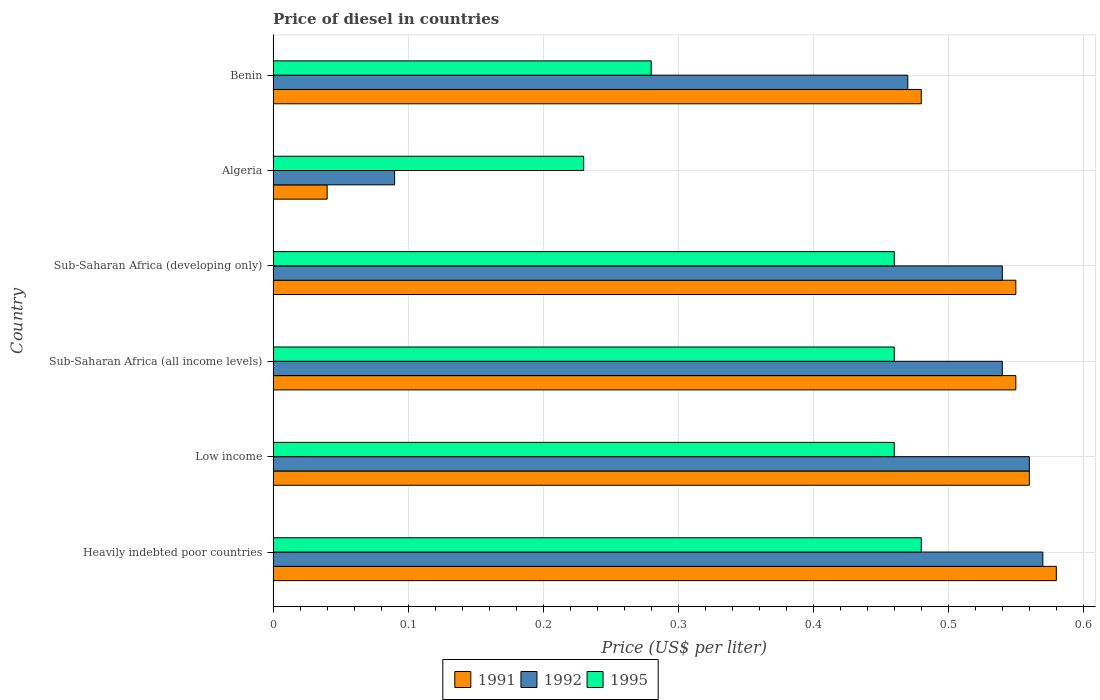How many different coloured bars are there?
Offer a very short reply. 3. How many groups of bars are there?
Ensure brevity in your answer.  6. How many bars are there on the 4th tick from the bottom?
Your response must be concise. 3. What is the label of the 3rd group of bars from the top?
Your answer should be very brief. Sub-Saharan Africa (developing only). What is the price of diesel in 1992 in Sub-Saharan Africa (developing only)?
Give a very brief answer. 0.54. Across all countries, what is the maximum price of diesel in 1991?
Keep it short and to the point. 0.58. Across all countries, what is the minimum price of diesel in 1992?
Your answer should be very brief. 0.09. In which country was the price of diesel in 1995 maximum?
Offer a terse response. Heavily indebted poor countries. In which country was the price of diesel in 1995 minimum?
Provide a succinct answer. Algeria. What is the total price of diesel in 1992 in the graph?
Offer a terse response. 2.77. What is the difference between the price of diesel in 1995 in Heavily indebted poor countries and that in Sub-Saharan Africa (developing only)?
Offer a very short reply. 0.02. What is the difference between the price of diesel in 1995 in Benin and the price of diesel in 1991 in Low income?
Your answer should be very brief. -0.28. What is the average price of diesel in 1992 per country?
Offer a very short reply. 0.46. What is the difference between the price of diesel in 1991 and price of diesel in 1992 in Sub-Saharan Africa (developing only)?
Your response must be concise. 0.01. What is the ratio of the price of diesel in 1991 in Sub-Saharan Africa (all income levels) to that in Sub-Saharan Africa (developing only)?
Your response must be concise. 1. Is the price of diesel in 1995 in Benin less than that in Sub-Saharan Africa (all income levels)?
Ensure brevity in your answer.  Yes. What is the difference between the highest and the second highest price of diesel in 1995?
Your response must be concise. 0.02. What is the difference between the highest and the lowest price of diesel in 1992?
Give a very brief answer. 0.48. In how many countries, is the price of diesel in 1992 greater than the average price of diesel in 1992 taken over all countries?
Offer a very short reply. 5. What does the 2nd bar from the top in Sub-Saharan Africa (developing only) represents?
Your answer should be very brief. 1992. Is it the case that in every country, the sum of the price of diesel in 1992 and price of diesel in 1995 is greater than the price of diesel in 1991?
Your answer should be compact. Yes. How many bars are there?
Provide a succinct answer. 18. Does the graph contain any zero values?
Offer a terse response. No. Does the graph contain grids?
Give a very brief answer. Yes. Where does the legend appear in the graph?
Offer a terse response. Bottom center. How many legend labels are there?
Give a very brief answer. 3. How are the legend labels stacked?
Your answer should be compact. Horizontal. What is the title of the graph?
Provide a succinct answer. Price of diesel in countries. Does "1969" appear as one of the legend labels in the graph?
Offer a very short reply. No. What is the label or title of the X-axis?
Ensure brevity in your answer.  Price (US$ per liter). What is the Price (US$ per liter) in 1991 in Heavily indebted poor countries?
Give a very brief answer. 0.58. What is the Price (US$ per liter) of 1992 in Heavily indebted poor countries?
Your answer should be very brief. 0.57. What is the Price (US$ per liter) in 1995 in Heavily indebted poor countries?
Keep it short and to the point. 0.48. What is the Price (US$ per liter) of 1991 in Low income?
Provide a succinct answer. 0.56. What is the Price (US$ per liter) in 1992 in Low income?
Give a very brief answer. 0.56. What is the Price (US$ per liter) in 1995 in Low income?
Your answer should be compact. 0.46. What is the Price (US$ per liter) in 1991 in Sub-Saharan Africa (all income levels)?
Offer a terse response. 0.55. What is the Price (US$ per liter) of 1992 in Sub-Saharan Africa (all income levels)?
Your answer should be compact. 0.54. What is the Price (US$ per liter) of 1995 in Sub-Saharan Africa (all income levels)?
Give a very brief answer. 0.46. What is the Price (US$ per liter) of 1991 in Sub-Saharan Africa (developing only)?
Provide a short and direct response. 0.55. What is the Price (US$ per liter) in 1992 in Sub-Saharan Africa (developing only)?
Your answer should be very brief. 0.54. What is the Price (US$ per liter) in 1995 in Sub-Saharan Africa (developing only)?
Your answer should be very brief. 0.46. What is the Price (US$ per liter) of 1992 in Algeria?
Give a very brief answer. 0.09. What is the Price (US$ per liter) in 1995 in Algeria?
Ensure brevity in your answer.  0.23. What is the Price (US$ per liter) in 1991 in Benin?
Your answer should be compact. 0.48. What is the Price (US$ per liter) in 1992 in Benin?
Your answer should be very brief. 0.47. What is the Price (US$ per liter) of 1995 in Benin?
Offer a terse response. 0.28. Across all countries, what is the maximum Price (US$ per liter) in 1991?
Give a very brief answer. 0.58. Across all countries, what is the maximum Price (US$ per liter) of 1992?
Offer a terse response. 0.57. Across all countries, what is the maximum Price (US$ per liter) in 1995?
Make the answer very short. 0.48. Across all countries, what is the minimum Price (US$ per liter) in 1992?
Keep it short and to the point. 0.09. Across all countries, what is the minimum Price (US$ per liter) in 1995?
Your answer should be very brief. 0.23. What is the total Price (US$ per liter) of 1991 in the graph?
Offer a very short reply. 2.76. What is the total Price (US$ per liter) in 1992 in the graph?
Provide a succinct answer. 2.77. What is the total Price (US$ per liter) of 1995 in the graph?
Ensure brevity in your answer.  2.37. What is the difference between the Price (US$ per liter) of 1995 in Heavily indebted poor countries and that in Sub-Saharan Africa (all income levels)?
Make the answer very short. 0.02. What is the difference between the Price (US$ per liter) in 1992 in Heavily indebted poor countries and that in Sub-Saharan Africa (developing only)?
Your response must be concise. 0.03. What is the difference between the Price (US$ per liter) of 1995 in Heavily indebted poor countries and that in Sub-Saharan Africa (developing only)?
Make the answer very short. 0.02. What is the difference between the Price (US$ per liter) in 1991 in Heavily indebted poor countries and that in Algeria?
Provide a short and direct response. 0.54. What is the difference between the Price (US$ per liter) in 1992 in Heavily indebted poor countries and that in Algeria?
Offer a terse response. 0.48. What is the difference between the Price (US$ per liter) in 1991 in Heavily indebted poor countries and that in Benin?
Give a very brief answer. 0.1. What is the difference between the Price (US$ per liter) of 1991 in Low income and that in Sub-Saharan Africa (all income levels)?
Keep it short and to the point. 0.01. What is the difference between the Price (US$ per liter) in 1995 in Low income and that in Sub-Saharan Africa (all income levels)?
Offer a very short reply. 0. What is the difference between the Price (US$ per liter) in 1992 in Low income and that in Sub-Saharan Africa (developing only)?
Provide a succinct answer. 0.02. What is the difference between the Price (US$ per liter) in 1991 in Low income and that in Algeria?
Keep it short and to the point. 0.52. What is the difference between the Price (US$ per liter) of 1992 in Low income and that in Algeria?
Your answer should be compact. 0.47. What is the difference between the Price (US$ per liter) of 1995 in Low income and that in Algeria?
Your response must be concise. 0.23. What is the difference between the Price (US$ per liter) in 1991 in Low income and that in Benin?
Your response must be concise. 0.08. What is the difference between the Price (US$ per liter) of 1992 in Low income and that in Benin?
Make the answer very short. 0.09. What is the difference between the Price (US$ per liter) of 1995 in Low income and that in Benin?
Offer a very short reply. 0.18. What is the difference between the Price (US$ per liter) in 1995 in Sub-Saharan Africa (all income levels) and that in Sub-Saharan Africa (developing only)?
Your response must be concise. 0. What is the difference between the Price (US$ per liter) of 1991 in Sub-Saharan Africa (all income levels) and that in Algeria?
Offer a very short reply. 0.51. What is the difference between the Price (US$ per liter) of 1992 in Sub-Saharan Africa (all income levels) and that in Algeria?
Your answer should be very brief. 0.45. What is the difference between the Price (US$ per liter) in 1995 in Sub-Saharan Africa (all income levels) and that in Algeria?
Provide a succinct answer. 0.23. What is the difference between the Price (US$ per liter) of 1991 in Sub-Saharan Africa (all income levels) and that in Benin?
Your answer should be compact. 0.07. What is the difference between the Price (US$ per liter) of 1992 in Sub-Saharan Africa (all income levels) and that in Benin?
Give a very brief answer. 0.07. What is the difference between the Price (US$ per liter) of 1995 in Sub-Saharan Africa (all income levels) and that in Benin?
Ensure brevity in your answer.  0.18. What is the difference between the Price (US$ per liter) of 1991 in Sub-Saharan Africa (developing only) and that in Algeria?
Offer a very short reply. 0.51. What is the difference between the Price (US$ per liter) of 1992 in Sub-Saharan Africa (developing only) and that in Algeria?
Offer a very short reply. 0.45. What is the difference between the Price (US$ per liter) of 1995 in Sub-Saharan Africa (developing only) and that in Algeria?
Your answer should be very brief. 0.23. What is the difference between the Price (US$ per liter) of 1991 in Sub-Saharan Africa (developing only) and that in Benin?
Keep it short and to the point. 0.07. What is the difference between the Price (US$ per liter) of 1992 in Sub-Saharan Africa (developing only) and that in Benin?
Your answer should be compact. 0.07. What is the difference between the Price (US$ per liter) of 1995 in Sub-Saharan Africa (developing only) and that in Benin?
Give a very brief answer. 0.18. What is the difference between the Price (US$ per liter) of 1991 in Algeria and that in Benin?
Provide a short and direct response. -0.44. What is the difference between the Price (US$ per liter) in 1992 in Algeria and that in Benin?
Make the answer very short. -0.38. What is the difference between the Price (US$ per liter) of 1995 in Algeria and that in Benin?
Your response must be concise. -0.05. What is the difference between the Price (US$ per liter) in 1991 in Heavily indebted poor countries and the Price (US$ per liter) in 1992 in Low income?
Give a very brief answer. 0.02. What is the difference between the Price (US$ per liter) in 1991 in Heavily indebted poor countries and the Price (US$ per liter) in 1995 in Low income?
Offer a terse response. 0.12. What is the difference between the Price (US$ per liter) in 1992 in Heavily indebted poor countries and the Price (US$ per liter) in 1995 in Low income?
Keep it short and to the point. 0.11. What is the difference between the Price (US$ per liter) of 1991 in Heavily indebted poor countries and the Price (US$ per liter) of 1992 in Sub-Saharan Africa (all income levels)?
Your response must be concise. 0.04. What is the difference between the Price (US$ per liter) in 1991 in Heavily indebted poor countries and the Price (US$ per liter) in 1995 in Sub-Saharan Africa (all income levels)?
Give a very brief answer. 0.12. What is the difference between the Price (US$ per liter) of 1992 in Heavily indebted poor countries and the Price (US$ per liter) of 1995 in Sub-Saharan Africa (all income levels)?
Give a very brief answer. 0.11. What is the difference between the Price (US$ per liter) in 1991 in Heavily indebted poor countries and the Price (US$ per liter) in 1995 in Sub-Saharan Africa (developing only)?
Your answer should be very brief. 0.12. What is the difference between the Price (US$ per liter) in 1992 in Heavily indebted poor countries and the Price (US$ per liter) in 1995 in Sub-Saharan Africa (developing only)?
Your response must be concise. 0.11. What is the difference between the Price (US$ per liter) in 1991 in Heavily indebted poor countries and the Price (US$ per liter) in 1992 in Algeria?
Your answer should be very brief. 0.49. What is the difference between the Price (US$ per liter) in 1991 in Heavily indebted poor countries and the Price (US$ per liter) in 1995 in Algeria?
Ensure brevity in your answer.  0.35. What is the difference between the Price (US$ per liter) in 1992 in Heavily indebted poor countries and the Price (US$ per liter) in 1995 in Algeria?
Your answer should be very brief. 0.34. What is the difference between the Price (US$ per liter) in 1991 in Heavily indebted poor countries and the Price (US$ per liter) in 1992 in Benin?
Make the answer very short. 0.11. What is the difference between the Price (US$ per liter) of 1992 in Heavily indebted poor countries and the Price (US$ per liter) of 1995 in Benin?
Ensure brevity in your answer.  0.29. What is the difference between the Price (US$ per liter) in 1991 in Low income and the Price (US$ per liter) in 1995 in Sub-Saharan Africa (all income levels)?
Give a very brief answer. 0.1. What is the difference between the Price (US$ per liter) of 1992 in Low income and the Price (US$ per liter) of 1995 in Sub-Saharan Africa (all income levels)?
Keep it short and to the point. 0.1. What is the difference between the Price (US$ per liter) of 1991 in Low income and the Price (US$ per liter) of 1992 in Algeria?
Your answer should be compact. 0.47. What is the difference between the Price (US$ per liter) in 1991 in Low income and the Price (US$ per liter) in 1995 in Algeria?
Provide a succinct answer. 0.33. What is the difference between the Price (US$ per liter) of 1992 in Low income and the Price (US$ per liter) of 1995 in Algeria?
Give a very brief answer. 0.33. What is the difference between the Price (US$ per liter) of 1991 in Low income and the Price (US$ per liter) of 1992 in Benin?
Your answer should be compact. 0.09. What is the difference between the Price (US$ per liter) of 1991 in Low income and the Price (US$ per liter) of 1995 in Benin?
Provide a short and direct response. 0.28. What is the difference between the Price (US$ per liter) in 1992 in Low income and the Price (US$ per liter) in 1995 in Benin?
Offer a very short reply. 0.28. What is the difference between the Price (US$ per liter) of 1991 in Sub-Saharan Africa (all income levels) and the Price (US$ per liter) of 1992 in Sub-Saharan Africa (developing only)?
Give a very brief answer. 0.01. What is the difference between the Price (US$ per liter) of 1991 in Sub-Saharan Africa (all income levels) and the Price (US$ per liter) of 1995 in Sub-Saharan Africa (developing only)?
Offer a very short reply. 0.09. What is the difference between the Price (US$ per liter) of 1992 in Sub-Saharan Africa (all income levels) and the Price (US$ per liter) of 1995 in Sub-Saharan Africa (developing only)?
Keep it short and to the point. 0.08. What is the difference between the Price (US$ per liter) of 1991 in Sub-Saharan Africa (all income levels) and the Price (US$ per liter) of 1992 in Algeria?
Ensure brevity in your answer.  0.46. What is the difference between the Price (US$ per liter) of 1991 in Sub-Saharan Africa (all income levels) and the Price (US$ per liter) of 1995 in Algeria?
Provide a succinct answer. 0.32. What is the difference between the Price (US$ per liter) of 1992 in Sub-Saharan Africa (all income levels) and the Price (US$ per liter) of 1995 in Algeria?
Ensure brevity in your answer.  0.31. What is the difference between the Price (US$ per liter) in 1991 in Sub-Saharan Africa (all income levels) and the Price (US$ per liter) in 1995 in Benin?
Offer a very short reply. 0.27. What is the difference between the Price (US$ per liter) in 1992 in Sub-Saharan Africa (all income levels) and the Price (US$ per liter) in 1995 in Benin?
Provide a short and direct response. 0.26. What is the difference between the Price (US$ per liter) of 1991 in Sub-Saharan Africa (developing only) and the Price (US$ per liter) of 1992 in Algeria?
Keep it short and to the point. 0.46. What is the difference between the Price (US$ per liter) in 1991 in Sub-Saharan Africa (developing only) and the Price (US$ per liter) in 1995 in Algeria?
Offer a terse response. 0.32. What is the difference between the Price (US$ per liter) in 1992 in Sub-Saharan Africa (developing only) and the Price (US$ per liter) in 1995 in Algeria?
Your answer should be very brief. 0.31. What is the difference between the Price (US$ per liter) of 1991 in Sub-Saharan Africa (developing only) and the Price (US$ per liter) of 1995 in Benin?
Offer a terse response. 0.27. What is the difference between the Price (US$ per liter) in 1992 in Sub-Saharan Africa (developing only) and the Price (US$ per liter) in 1995 in Benin?
Your answer should be very brief. 0.26. What is the difference between the Price (US$ per liter) in 1991 in Algeria and the Price (US$ per liter) in 1992 in Benin?
Keep it short and to the point. -0.43. What is the difference between the Price (US$ per liter) in 1991 in Algeria and the Price (US$ per liter) in 1995 in Benin?
Provide a succinct answer. -0.24. What is the difference between the Price (US$ per liter) of 1992 in Algeria and the Price (US$ per liter) of 1995 in Benin?
Provide a short and direct response. -0.19. What is the average Price (US$ per liter) of 1991 per country?
Offer a terse response. 0.46. What is the average Price (US$ per liter) in 1992 per country?
Offer a very short reply. 0.46. What is the average Price (US$ per liter) of 1995 per country?
Keep it short and to the point. 0.4. What is the difference between the Price (US$ per liter) in 1991 and Price (US$ per liter) in 1992 in Heavily indebted poor countries?
Provide a short and direct response. 0.01. What is the difference between the Price (US$ per liter) in 1992 and Price (US$ per liter) in 1995 in Heavily indebted poor countries?
Your answer should be compact. 0.09. What is the difference between the Price (US$ per liter) of 1991 and Price (US$ per liter) of 1992 in Low income?
Your answer should be compact. 0. What is the difference between the Price (US$ per liter) in 1992 and Price (US$ per liter) in 1995 in Low income?
Your answer should be very brief. 0.1. What is the difference between the Price (US$ per liter) of 1991 and Price (US$ per liter) of 1992 in Sub-Saharan Africa (all income levels)?
Your answer should be very brief. 0.01. What is the difference between the Price (US$ per liter) of 1991 and Price (US$ per liter) of 1995 in Sub-Saharan Africa (all income levels)?
Provide a succinct answer. 0.09. What is the difference between the Price (US$ per liter) in 1992 and Price (US$ per liter) in 1995 in Sub-Saharan Africa (all income levels)?
Your answer should be very brief. 0.08. What is the difference between the Price (US$ per liter) in 1991 and Price (US$ per liter) in 1995 in Sub-Saharan Africa (developing only)?
Your answer should be very brief. 0.09. What is the difference between the Price (US$ per liter) of 1991 and Price (US$ per liter) of 1992 in Algeria?
Offer a terse response. -0.05. What is the difference between the Price (US$ per liter) of 1991 and Price (US$ per liter) of 1995 in Algeria?
Your answer should be very brief. -0.19. What is the difference between the Price (US$ per liter) of 1992 and Price (US$ per liter) of 1995 in Algeria?
Make the answer very short. -0.14. What is the difference between the Price (US$ per liter) in 1991 and Price (US$ per liter) in 1992 in Benin?
Provide a succinct answer. 0.01. What is the difference between the Price (US$ per liter) in 1991 and Price (US$ per liter) in 1995 in Benin?
Make the answer very short. 0.2. What is the difference between the Price (US$ per liter) of 1992 and Price (US$ per liter) of 1995 in Benin?
Make the answer very short. 0.19. What is the ratio of the Price (US$ per liter) in 1991 in Heavily indebted poor countries to that in Low income?
Your answer should be very brief. 1.04. What is the ratio of the Price (US$ per liter) in 1992 in Heavily indebted poor countries to that in Low income?
Offer a terse response. 1.02. What is the ratio of the Price (US$ per liter) of 1995 in Heavily indebted poor countries to that in Low income?
Your answer should be very brief. 1.04. What is the ratio of the Price (US$ per liter) of 1991 in Heavily indebted poor countries to that in Sub-Saharan Africa (all income levels)?
Your answer should be compact. 1.05. What is the ratio of the Price (US$ per liter) of 1992 in Heavily indebted poor countries to that in Sub-Saharan Africa (all income levels)?
Your response must be concise. 1.06. What is the ratio of the Price (US$ per liter) of 1995 in Heavily indebted poor countries to that in Sub-Saharan Africa (all income levels)?
Offer a terse response. 1.04. What is the ratio of the Price (US$ per liter) in 1991 in Heavily indebted poor countries to that in Sub-Saharan Africa (developing only)?
Your answer should be very brief. 1.05. What is the ratio of the Price (US$ per liter) of 1992 in Heavily indebted poor countries to that in Sub-Saharan Africa (developing only)?
Provide a short and direct response. 1.06. What is the ratio of the Price (US$ per liter) in 1995 in Heavily indebted poor countries to that in Sub-Saharan Africa (developing only)?
Offer a terse response. 1.04. What is the ratio of the Price (US$ per liter) in 1992 in Heavily indebted poor countries to that in Algeria?
Your answer should be very brief. 6.33. What is the ratio of the Price (US$ per liter) in 1995 in Heavily indebted poor countries to that in Algeria?
Make the answer very short. 2.09. What is the ratio of the Price (US$ per liter) of 1991 in Heavily indebted poor countries to that in Benin?
Ensure brevity in your answer.  1.21. What is the ratio of the Price (US$ per liter) in 1992 in Heavily indebted poor countries to that in Benin?
Make the answer very short. 1.21. What is the ratio of the Price (US$ per liter) of 1995 in Heavily indebted poor countries to that in Benin?
Your answer should be very brief. 1.71. What is the ratio of the Price (US$ per liter) in 1991 in Low income to that in Sub-Saharan Africa (all income levels)?
Offer a very short reply. 1.02. What is the ratio of the Price (US$ per liter) in 1992 in Low income to that in Sub-Saharan Africa (all income levels)?
Give a very brief answer. 1.04. What is the ratio of the Price (US$ per liter) in 1995 in Low income to that in Sub-Saharan Africa (all income levels)?
Your answer should be very brief. 1. What is the ratio of the Price (US$ per liter) of 1991 in Low income to that in Sub-Saharan Africa (developing only)?
Offer a very short reply. 1.02. What is the ratio of the Price (US$ per liter) of 1992 in Low income to that in Sub-Saharan Africa (developing only)?
Your response must be concise. 1.04. What is the ratio of the Price (US$ per liter) in 1991 in Low income to that in Algeria?
Your answer should be very brief. 14. What is the ratio of the Price (US$ per liter) of 1992 in Low income to that in Algeria?
Give a very brief answer. 6.22. What is the ratio of the Price (US$ per liter) of 1992 in Low income to that in Benin?
Your response must be concise. 1.19. What is the ratio of the Price (US$ per liter) of 1995 in Low income to that in Benin?
Ensure brevity in your answer.  1.64. What is the ratio of the Price (US$ per liter) in 1991 in Sub-Saharan Africa (all income levels) to that in Algeria?
Offer a very short reply. 13.75. What is the ratio of the Price (US$ per liter) in 1992 in Sub-Saharan Africa (all income levels) to that in Algeria?
Provide a succinct answer. 6. What is the ratio of the Price (US$ per liter) in 1991 in Sub-Saharan Africa (all income levels) to that in Benin?
Provide a succinct answer. 1.15. What is the ratio of the Price (US$ per liter) of 1992 in Sub-Saharan Africa (all income levels) to that in Benin?
Give a very brief answer. 1.15. What is the ratio of the Price (US$ per liter) in 1995 in Sub-Saharan Africa (all income levels) to that in Benin?
Keep it short and to the point. 1.64. What is the ratio of the Price (US$ per liter) of 1991 in Sub-Saharan Africa (developing only) to that in Algeria?
Provide a short and direct response. 13.75. What is the ratio of the Price (US$ per liter) of 1992 in Sub-Saharan Africa (developing only) to that in Algeria?
Your answer should be very brief. 6. What is the ratio of the Price (US$ per liter) of 1991 in Sub-Saharan Africa (developing only) to that in Benin?
Your response must be concise. 1.15. What is the ratio of the Price (US$ per liter) in 1992 in Sub-Saharan Africa (developing only) to that in Benin?
Your answer should be compact. 1.15. What is the ratio of the Price (US$ per liter) in 1995 in Sub-Saharan Africa (developing only) to that in Benin?
Provide a succinct answer. 1.64. What is the ratio of the Price (US$ per liter) of 1991 in Algeria to that in Benin?
Give a very brief answer. 0.08. What is the ratio of the Price (US$ per liter) of 1992 in Algeria to that in Benin?
Provide a short and direct response. 0.19. What is the ratio of the Price (US$ per liter) in 1995 in Algeria to that in Benin?
Offer a terse response. 0.82. What is the difference between the highest and the second highest Price (US$ per liter) of 1992?
Your response must be concise. 0.01. What is the difference between the highest and the lowest Price (US$ per liter) in 1991?
Offer a very short reply. 0.54. What is the difference between the highest and the lowest Price (US$ per liter) in 1992?
Make the answer very short. 0.48. 